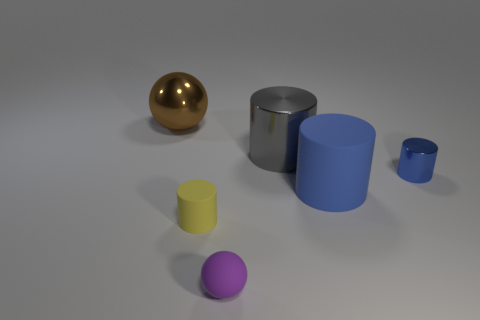Add 2 spheres. How many objects exist? 8 Subtract all spheres. How many objects are left? 4 Subtract 0 red blocks. How many objects are left? 6 Subtract all large gray shiny objects. Subtract all large blue rubber cylinders. How many objects are left? 4 Add 1 big spheres. How many big spheres are left? 2 Add 1 big shiny balls. How many big shiny balls exist? 2 